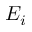<formula> <loc_0><loc_0><loc_500><loc_500>E _ { i }</formula> 